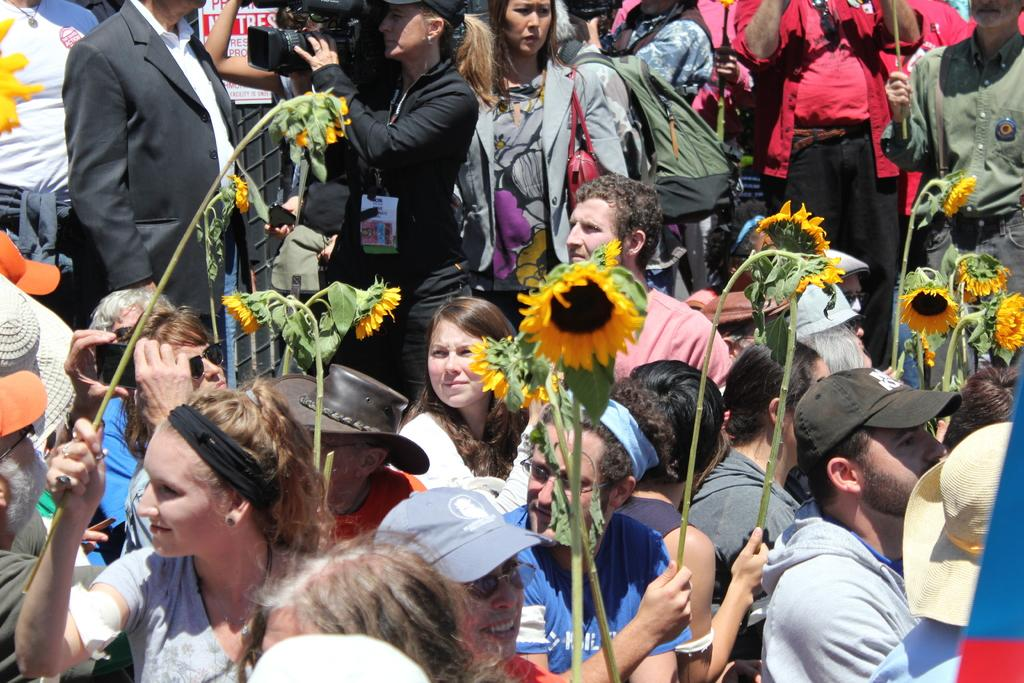What can be observed about the people in the image? There is a group of people in the image. What are some of the people in the group holding? Some people in the group are holding flowers. Can you describe the woman in the group? The woman in the group is holding a camera. How many beds are visible in the image? There are no beds present in the image. Is there a cactus in the image? There is no cactus visible in the image. 